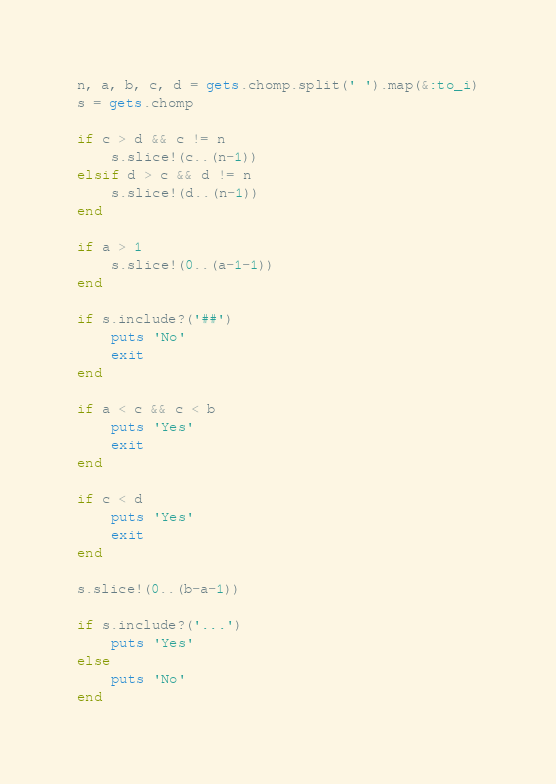<code> <loc_0><loc_0><loc_500><loc_500><_Ruby_>n, a, b, c, d = gets.chomp.split(' ').map(&:to_i)
s = gets.chomp

if c > d && c != n
	s.slice!(c..(n-1))
elsif d > c && d != n
	s.slice!(d..(n-1))
end

if a > 1
	s.slice!(0..(a-1-1))
end

if s.include?('##')
	puts 'No'
	exit
end

if a < c && c < b
	puts 'Yes'
	exit
end

if c < d
	puts 'Yes'
	exit
end

s.slice!(0..(b-a-1))

if s.include?('...')
	puts 'Yes'
else
	puts 'No'
end
</code> 